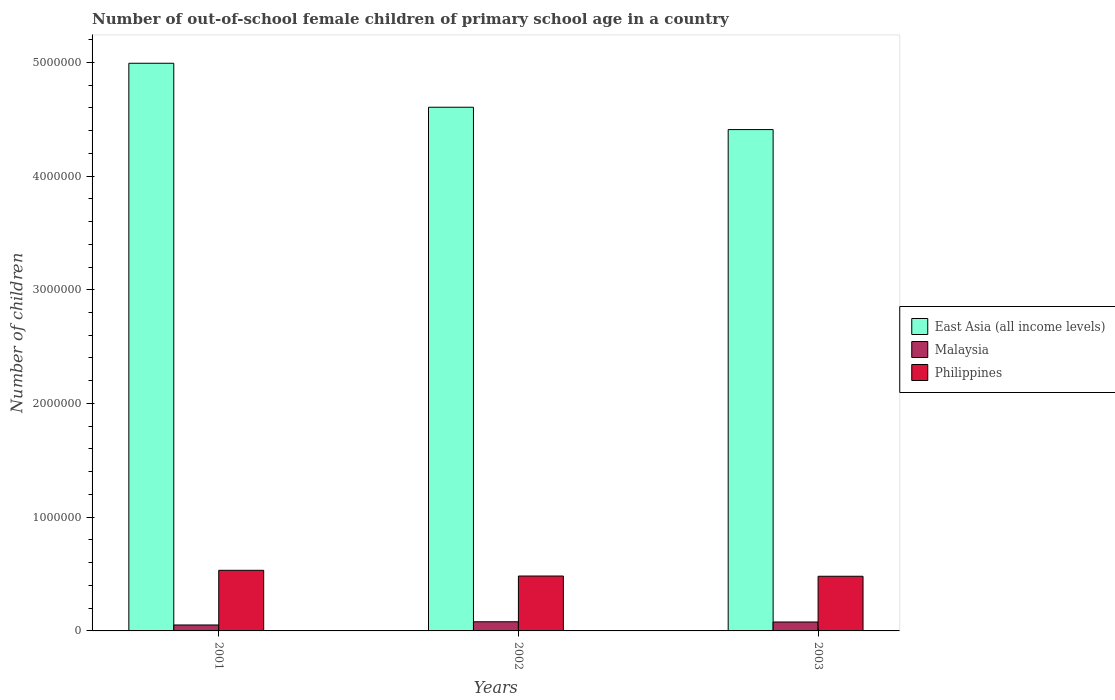How many different coloured bars are there?
Provide a short and direct response. 3. How many groups of bars are there?
Your answer should be very brief. 3. Are the number of bars on each tick of the X-axis equal?
Make the answer very short. Yes. What is the number of out-of-school female children in East Asia (all income levels) in 2003?
Offer a terse response. 4.41e+06. Across all years, what is the maximum number of out-of-school female children in East Asia (all income levels)?
Give a very brief answer. 4.99e+06. Across all years, what is the minimum number of out-of-school female children in Malaysia?
Give a very brief answer. 5.23e+04. In which year was the number of out-of-school female children in East Asia (all income levels) maximum?
Provide a short and direct response. 2001. What is the total number of out-of-school female children in Malaysia in the graph?
Provide a succinct answer. 2.11e+05. What is the difference between the number of out-of-school female children in East Asia (all income levels) in 2001 and that in 2003?
Your response must be concise. 5.83e+05. What is the difference between the number of out-of-school female children in East Asia (all income levels) in 2001 and the number of out-of-school female children in Philippines in 2002?
Provide a short and direct response. 4.51e+06. What is the average number of out-of-school female children in Malaysia per year?
Your response must be concise. 7.04e+04. In the year 2003, what is the difference between the number of out-of-school female children in East Asia (all income levels) and number of out-of-school female children in Philippines?
Ensure brevity in your answer.  3.93e+06. What is the ratio of the number of out-of-school female children in East Asia (all income levels) in 2002 to that in 2003?
Ensure brevity in your answer.  1.04. Is the difference between the number of out-of-school female children in East Asia (all income levels) in 2002 and 2003 greater than the difference between the number of out-of-school female children in Philippines in 2002 and 2003?
Make the answer very short. Yes. What is the difference between the highest and the second highest number of out-of-school female children in Philippines?
Give a very brief answer. 5.02e+04. What is the difference between the highest and the lowest number of out-of-school female children in Malaysia?
Your answer should be very brief. 2.81e+04. In how many years, is the number of out-of-school female children in Philippines greater than the average number of out-of-school female children in Philippines taken over all years?
Make the answer very short. 1. What does the 1st bar from the left in 2003 represents?
Make the answer very short. East Asia (all income levels). What does the 3rd bar from the right in 2003 represents?
Your response must be concise. East Asia (all income levels). Is it the case that in every year, the sum of the number of out-of-school female children in Malaysia and number of out-of-school female children in East Asia (all income levels) is greater than the number of out-of-school female children in Philippines?
Provide a succinct answer. Yes. How many bars are there?
Provide a succinct answer. 9. What is the difference between two consecutive major ticks on the Y-axis?
Provide a succinct answer. 1.00e+06. Are the values on the major ticks of Y-axis written in scientific E-notation?
Keep it short and to the point. No. Does the graph contain grids?
Your response must be concise. No. Where does the legend appear in the graph?
Provide a succinct answer. Center right. How many legend labels are there?
Ensure brevity in your answer.  3. What is the title of the graph?
Provide a short and direct response. Number of out-of-school female children of primary school age in a country. What is the label or title of the Y-axis?
Provide a short and direct response. Number of children. What is the Number of children of East Asia (all income levels) in 2001?
Make the answer very short. 4.99e+06. What is the Number of children in Malaysia in 2001?
Provide a succinct answer. 5.23e+04. What is the Number of children in Philippines in 2001?
Keep it short and to the point. 5.33e+05. What is the Number of children of East Asia (all income levels) in 2002?
Provide a short and direct response. 4.61e+06. What is the Number of children of Malaysia in 2002?
Your response must be concise. 8.04e+04. What is the Number of children in Philippines in 2002?
Ensure brevity in your answer.  4.83e+05. What is the Number of children in East Asia (all income levels) in 2003?
Provide a succinct answer. 4.41e+06. What is the Number of children in Malaysia in 2003?
Give a very brief answer. 7.86e+04. What is the Number of children of Philippines in 2003?
Offer a terse response. 4.81e+05. Across all years, what is the maximum Number of children of East Asia (all income levels)?
Your answer should be compact. 4.99e+06. Across all years, what is the maximum Number of children in Malaysia?
Your answer should be very brief. 8.04e+04. Across all years, what is the maximum Number of children in Philippines?
Keep it short and to the point. 5.33e+05. Across all years, what is the minimum Number of children of East Asia (all income levels)?
Provide a succinct answer. 4.41e+06. Across all years, what is the minimum Number of children of Malaysia?
Keep it short and to the point. 5.23e+04. Across all years, what is the minimum Number of children in Philippines?
Give a very brief answer. 4.81e+05. What is the total Number of children of East Asia (all income levels) in the graph?
Your answer should be compact. 1.40e+07. What is the total Number of children of Malaysia in the graph?
Give a very brief answer. 2.11e+05. What is the total Number of children of Philippines in the graph?
Make the answer very short. 1.50e+06. What is the difference between the Number of children in East Asia (all income levels) in 2001 and that in 2002?
Keep it short and to the point. 3.87e+05. What is the difference between the Number of children of Malaysia in 2001 and that in 2002?
Offer a terse response. -2.81e+04. What is the difference between the Number of children of Philippines in 2001 and that in 2002?
Provide a succinct answer. 5.02e+04. What is the difference between the Number of children of East Asia (all income levels) in 2001 and that in 2003?
Give a very brief answer. 5.83e+05. What is the difference between the Number of children of Malaysia in 2001 and that in 2003?
Make the answer very short. -2.63e+04. What is the difference between the Number of children of Philippines in 2001 and that in 2003?
Give a very brief answer. 5.24e+04. What is the difference between the Number of children of East Asia (all income levels) in 2002 and that in 2003?
Offer a very short reply. 1.97e+05. What is the difference between the Number of children of Malaysia in 2002 and that in 2003?
Make the answer very short. 1818. What is the difference between the Number of children of Philippines in 2002 and that in 2003?
Your answer should be compact. 2153. What is the difference between the Number of children in East Asia (all income levels) in 2001 and the Number of children in Malaysia in 2002?
Make the answer very short. 4.91e+06. What is the difference between the Number of children in East Asia (all income levels) in 2001 and the Number of children in Philippines in 2002?
Provide a succinct answer. 4.51e+06. What is the difference between the Number of children in Malaysia in 2001 and the Number of children in Philippines in 2002?
Ensure brevity in your answer.  -4.31e+05. What is the difference between the Number of children of East Asia (all income levels) in 2001 and the Number of children of Malaysia in 2003?
Give a very brief answer. 4.91e+06. What is the difference between the Number of children in East Asia (all income levels) in 2001 and the Number of children in Philippines in 2003?
Your answer should be very brief. 4.51e+06. What is the difference between the Number of children of Malaysia in 2001 and the Number of children of Philippines in 2003?
Your response must be concise. -4.28e+05. What is the difference between the Number of children in East Asia (all income levels) in 2002 and the Number of children in Malaysia in 2003?
Provide a short and direct response. 4.53e+06. What is the difference between the Number of children in East Asia (all income levels) in 2002 and the Number of children in Philippines in 2003?
Your response must be concise. 4.12e+06. What is the difference between the Number of children in Malaysia in 2002 and the Number of children in Philippines in 2003?
Offer a very short reply. -4.00e+05. What is the average Number of children in East Asia (all income levels) per year?
Provide a short and direct response. 4.67e+06. What is the average Number of children of Malaysia per year?
Your answer should be compact. 7.04e+04. What is the average Number of children in Philippines per year?
Keep it short and to the point. 4.99e+05. In the year 2001, what is the difference between the Number of children in East Asia (all income levels) and Number of children in Malaysia?
Provide a short and direct response. 4.94e+06. In the year 2001, what is the difference between the Number of children of East Asia (all income levels) and Number of children of Philippines?
Your response must be concise. 4.46e+06. In the year 2001, what is the difference between the Number of children of Malaysia and Number of children of Philippines?
Ensure brevity in your answer.  -4.81e+05. In the year 2002, what is the difference between the Number of children in East Asia (all income levels) and Number of children in Malaysia?
Your answer should be very brief. 4.52e+06. In the year 2002, what is the difference between the Number of children of East Asia (all income levels) and Number of children of Philippines?
Make the answer very short. 4.12e+06. In the year 2002, what is the difference between the Number of children of Malaysia and Number of children of Philippines?
Keep it short and to the point. -4.02e+05. In the year 2003, what is the difference between the Number of children of East Asia (all income levels) and Number of children of Malaysia?
Give a very brief answer. 4.33e+06. In the year 2003, what is the difference between the Number of children of East Asia (all income levels) and Number of children of Philippines?
Offer a terse response. 3.93e+06. In the year 2003, what is the difference between the Number of children in Malaysia and Number of children in Philippines?
Keep it short and to the point. -4.02e+05. What is the ratio of the Number of children of East Asia (all income levels) in 2001 to that in 2002?
Your response must be concise. 1.08. What is the ratio of the Number of children in Malaysia in 2001 to that in 2002?
Your answer should be compact. 0.65. What is the ratio of the Number of children in Philippines in 2001 to that in 2002?
Offer a terse response. 1.1. What is the ratio of the Number of children of East Asia (all income levels) in 2001 to that in 2003?
Make the answer very short. 1.13. What is the ratio of the Number of children of Malaysia in 2001 to that in 2003?
Provide a short and direct response. 0.67. What is the ratio of the Number of children in Philippines in 2001 to that in 2003?
Your answer should be compact. 1.11. What is the ratio of the Number of children in East Asia (all income levels) in 2002 to that in 2003?
Provide a succinct answer. 1.04. What is the ratio of the Number of children of Malaysia in 2002 to that in 2003?
Offer a terse response. 1.02. What is the ratio of the Number of children in Philippines in 2002 to that in 2003?
Provide a succinct answer. 1. What is the difference between the highest and the second highest Number of children in East Asia (all income levels)?
Make the answer very short. 3.87e+05. What is the difference between the highest and the second highest Number of children of Malaysia?
Give a very brief answer. 1818. What is the difference between the highest and the second highest Number of children of Philippines?
Your answer should be compact. 5.02e+04. What is the difference between the highest and the lowest Number of children in East Asia (all income levels)?
Give a very brief answer. 5.83e+05. What is the difference between the highest and the lowest Number of children in Malaysia?
Provide a succinct answer. 2.81e+04. What is the difference between the highest and the lowest Number of children of Philippines?
Provide a succinct answer. 5.24e+04. 